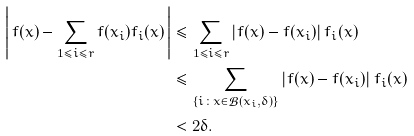Convert formula to latex. <formula><loc_0><loc_0><loc_500><loc_500>\left | \, f ( x ) - \sum _ { 1 \leq i \leq r } f ( x _ { i } ) f _ { i } ( x ) \, \right | & \leq \sum _ { 1 \leq i \leq r } | f ( x ) - f ( x _ { i } ) | \, f _ { i } ( x ) \\ & \leq \sum _ { \{ i \colon x \in \mathcal { B } ( x _ { i } , \delta ) \} } | f ( x ) - f ( x _ { i } ) | \, f _ { i } ( x ) \\ & < 2 \delta .</formula> 